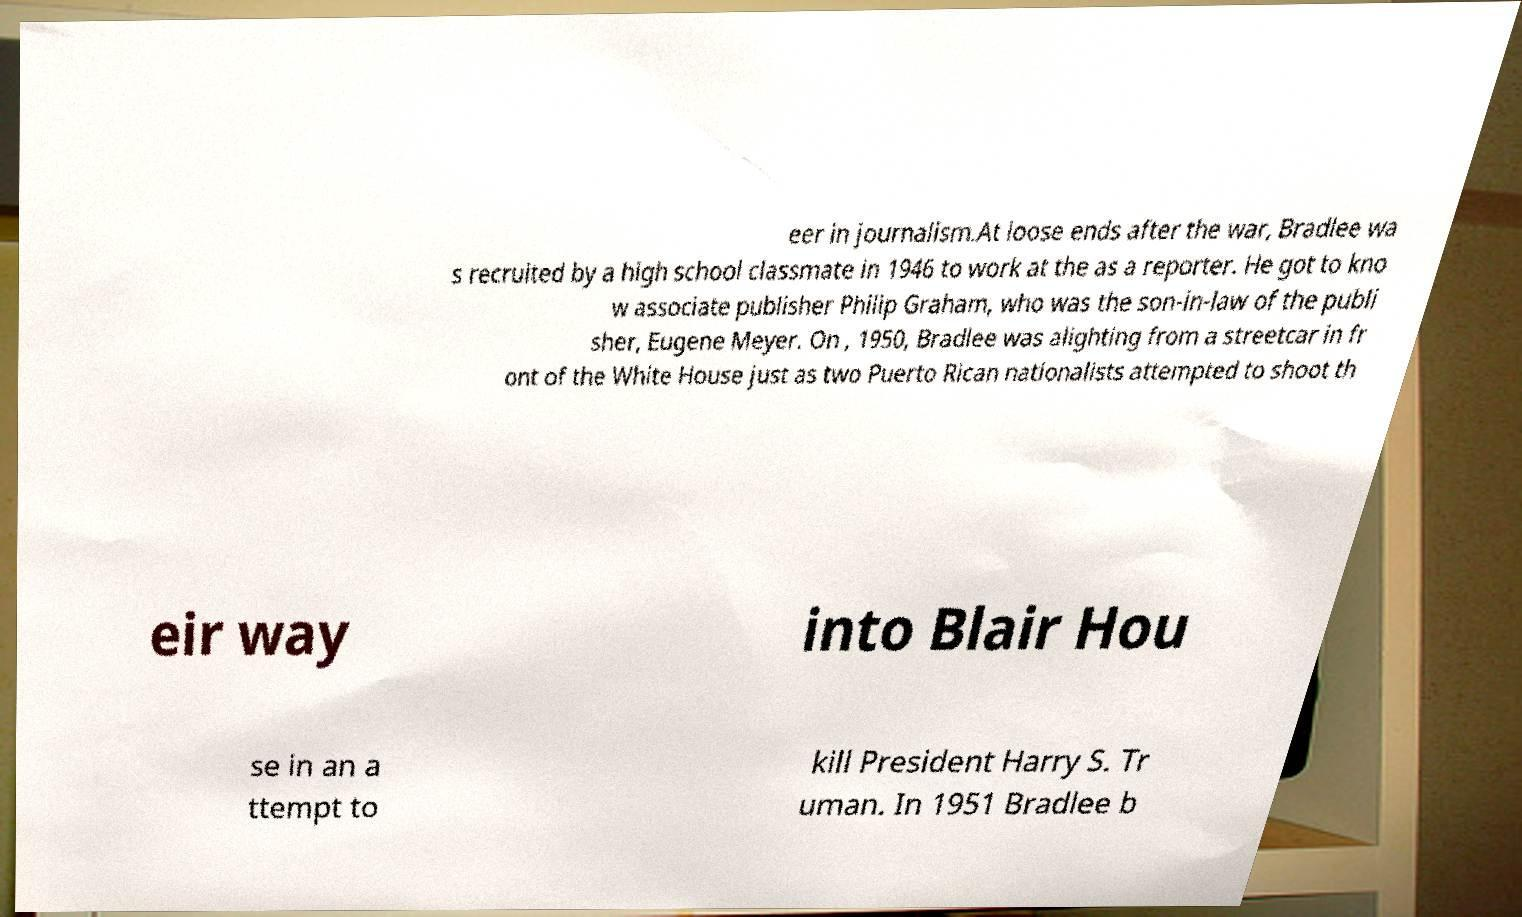There's text embedded in this image that I need extracted. Can you transcribe it verbatim? eer in journalism.At loose ends after the war, Bradlee wa s recruited by a high school classmate in 1946 to work at the as a reporter. He got to kno w associate publisher Philip Graham, who was the son-in-law of the publi sher, Eugene Meyer. On , 1950, Bradlee was alighting from a streetcar in fr ont of the White House just as two Puerto Rican nationalists attempted to shoot th eir way into Blair Hou se in an a ttempt to kill President Harry S. Tr uman. In 1951 Bradlee b 